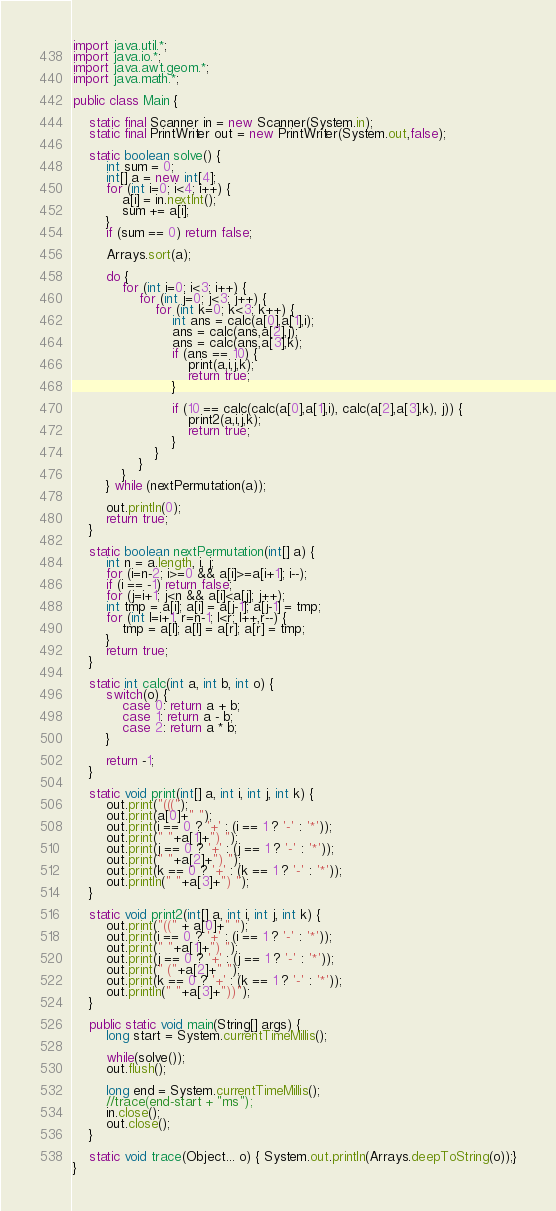Convert code to text. <code><loc_0><loc_0><loc_500><loc_500><_Java_>import java.util.*;
import java.io.*;
import java.awt.geom.*;
import java.math.*;

public class Main {

	static final Scanner in = new Scanner(System.in);
	static final PrintWriter out = new PrintWriter(System.out,false);

	static boolean solve() {
		int sum = 0;
		int[] a = new int[4];
		for (int i=0; i<4; i++) {
			a[i] = in.nextInt();
			sum += a[i];
		}
		if (sum == 0) return false;

		Arrays.sort(a);

		do {
			for (int i=0; i<3; i++) {
				for (int j=0; j<3; j++) {
					for (int k=0; k<3; k++) {
						int ans = calc(a[0],a[1],i);
						ans = calc(ans,a[2],j);
						ans = calc(ans,a[3],k);
						if (ans == 10) {
							print(a,i,j,k);
							return true;
						}

						if (10 == calc(calc(a[0],a[1],i), calc(a[2],a[3],k), j)) {
							print2(a,i,j,k);
							return true;
						}
					}
				}
			}
		} while (nextPermutation(a));

		out.println(0);
		return true;
	}

	static boolean nextPermutation(int[] a) {
		int n = a.length, i, j;
		for (i=n-2; i>=0 && a[i]>=a[i+1]; i--);
		if (i == -1) return false;
		for (j=i+1; j<n && a[i]<a[j]; j++);
		int tmp = a[i]; a[i] = a[j-1]; a[j-1] = tmp;
		for (int l=i+1, r=n-1; l<r; l++,r--) {
			tmp = a[l]; a[l] = a[r]; a[r] = tmp;
		}
		return true;
	}

	static int calc(int a, int b, int o) {
		switch(o) {
			case 0: return a + b;
			case 1: return a - b;
			case 2: return a * b;
		}

		return -1;
	}

	static void print(int[] a, int i, int j, int k) {
		out.print("(((");
		out.print(a[0]+" ");
		out.print(i == 0 ? '+' : (i == 1 ? '-' : '*'));
		out.print(" "+a[1]+") ");
		out.print(j == 0 ? '+' : (j == 1 ? '-' : '*'));
		out.print(" "+a[2]+") ");
		out.print(k == 0 ? '+' : (k == 1 ? '-' : '*'));
		out.println(" "+a[3]+") ");
	}

	static void print2(int[] a, int i, int j, int k) {
		out.print("((" + a[0]+" ");
		out.print(i == 0 ? '+' : (i == 1 ? '-' : '*'));
		out.print(" "+a[1]+") ");
		out.print(j == 0 ? '+' : (j == 1 ? '-' : '*'));
		out.print(" ("+a[2]+" ");
		out.print(k == 0 ? '+' : (k == 1 ? '-' : '*'));
		out.println(" "+a[3]+"))");
	}

	public static void main(String[] args) {
		long start = System.currentTimeMillis();

		while(solve());
		out.flush();

		long end = System.currentTimeMillis();
		//trace(end-start + "ms");
		in.close();
		out.close();
	}

	static void trace(Object... o) { System.out.println(Arrays.deepToString(o));}
}</code> 